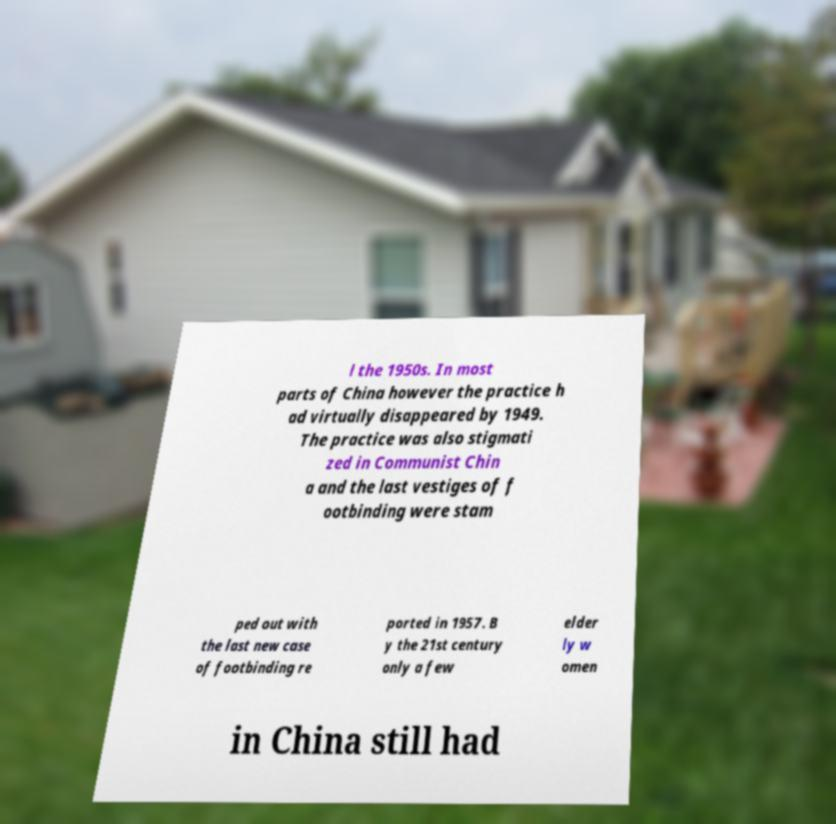Can you read and provide the text displayed in the image?This photo seems to have some interesting text. Can you extract and type it out for me? l the 1950s. In most parts of China however the practice h ad virtually disappeared by 1949. The practice was also stigmati zed in Communist Chin a and the last vestiges of f ootbinding were stam ped out with the last new case of footbinding re ported in 1957. B y the 21st century only a few elder ly w omen in China still had 